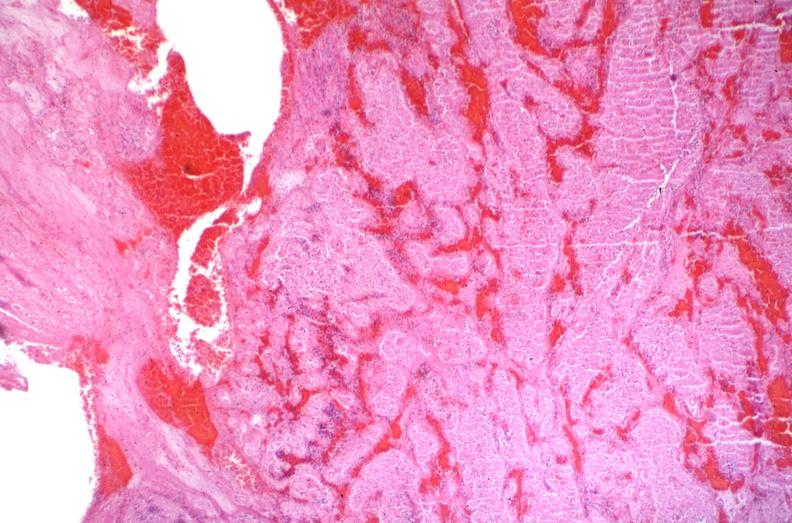what is present?
Answer the question using a single word or phrase. Vasculature 